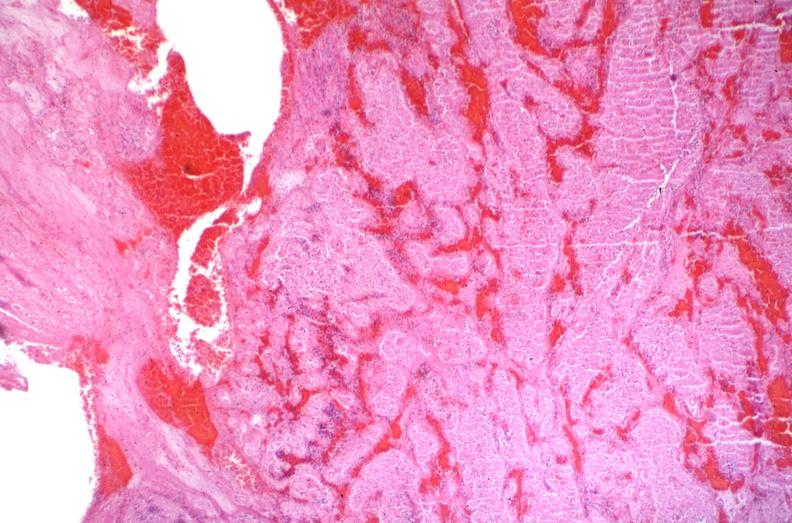what is present?
Answer the question using a single word or phrase. Vasculature 